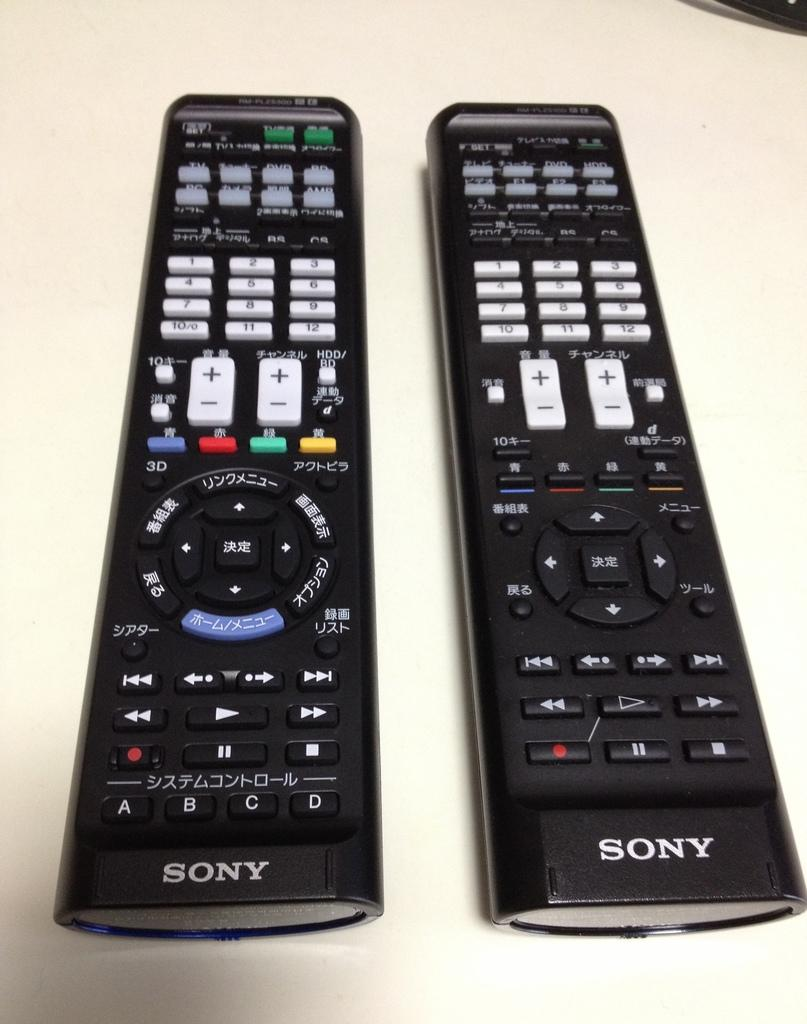<image>
Share a concise interpretation of the image provided. two sony remotes that have asian characters on them 